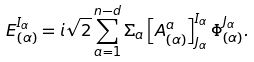<formula> <loc_0><loc_0><loc_500><loc_500>E _ { ( \alpha ) } ^ { I _ { \alpha } } = i \sqrt { 2 } \sum _ { a = 1 } ^ { n - d } \Sigma _ { a } \left [ A _ { ( \alpha ) } ^ { a } \right ] ^ { I _ { \alpha } } _ { J _ { \alpha } } \Phi _ { ( \alpha ) } ^ { J _ { \alpha } } .</formula> 